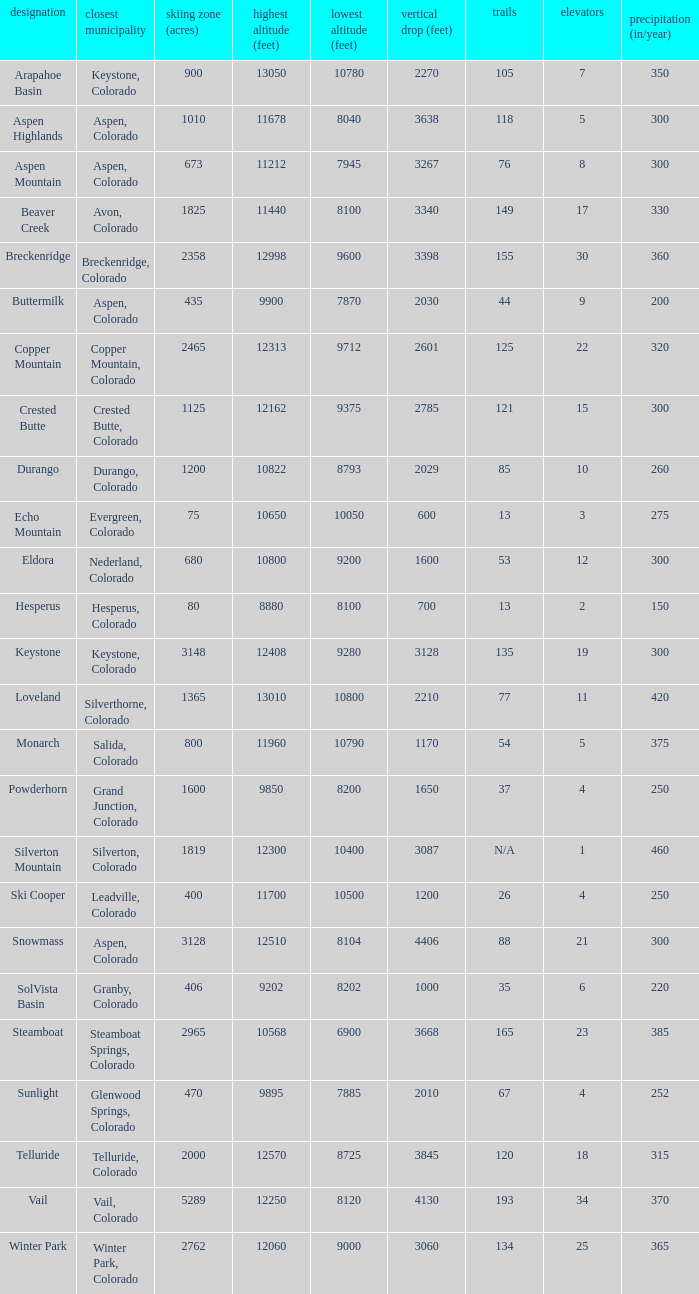If the name is Steamboat, what is the top elevation? 10568.0. 